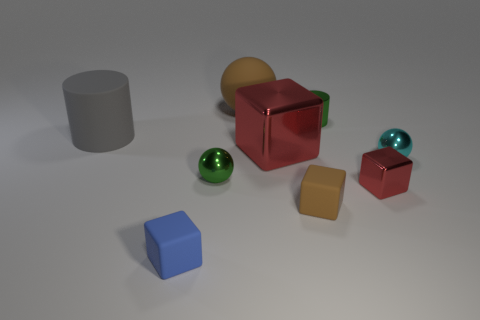Add 1 tiny cylinders. How many objects exist? 10 Subtract all purple cubes. Subtract all yellow spheres. How many cubes are left? 4 Subtract all spheres. How many objects are left? 6 Add 1 blue blocks. How many blue blocks are left? 2 Add 2 large brown rubber balls. How many large brown rubber balls exist? 3 Subtract 0 purple blocks. How many objects are left? 9 Subtract all gray rubber things. Subtract all big gray things. How many objects are left? 7 